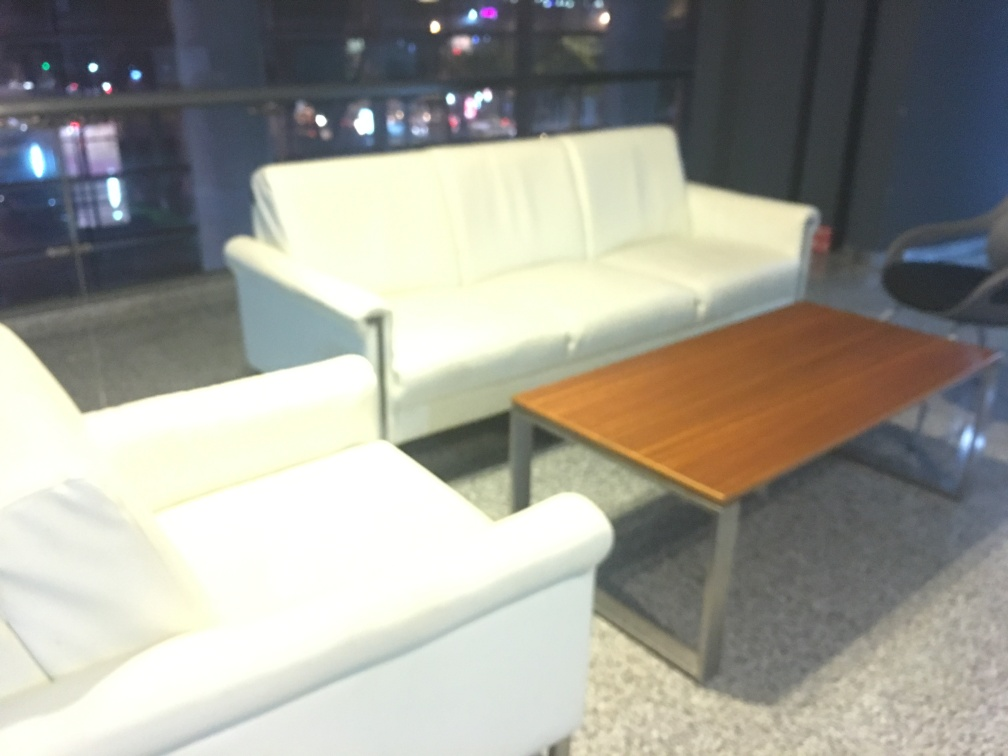What time of day does this photo seem to be taken, based on the lighting and surroundings? The photo seems to be taken during the evening or night hours. This assumption is based on the presence of city lights visible through the window in the background, alongside the interior lighting that is subtly illuminating the space. The soft glow of the lights reflecting off the furniture and floors further supports the idea of an indoor environment at a time when natural daylight has faded. 